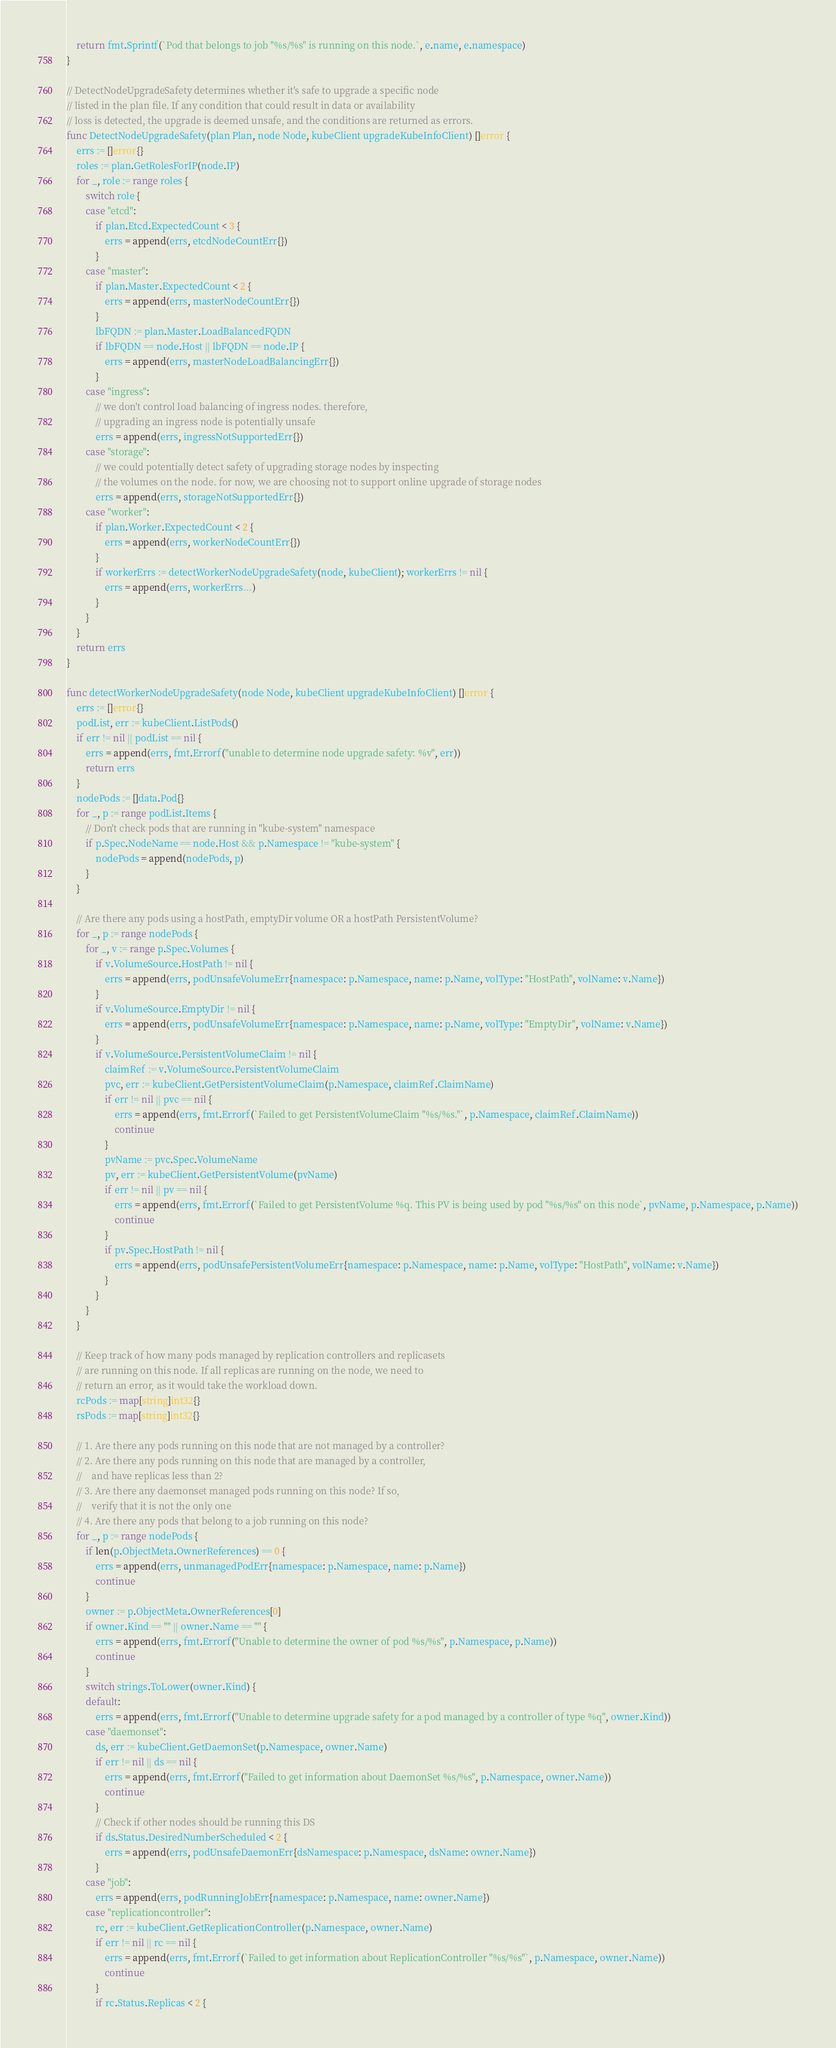<code> <loc_0><loc_0><loc_500><loc_500><_Go_>	return fmt.Sprintf(`Pod that belongs to job "%s/%s" is running on this node.`, e.name, e.namespace)
}

// DetectNodeUpgradeSafety determines whether it's safe to upgrade a specific node
// listed in the plan file. If any condition that could result in data or availability
// loss is detected, the upgrade is deemed unsafe, and the conditions are returned as errors.
func DetectNodeUpgradeSafety(plan Plan, node Node, kubeClient upgradeKubeInfoClient) []error {
	errs := []error{}
	roles := plan.GetRolesForIP(node.IP)
	for _, role := range roles {
		switch role {
		case "etcd":
			if plan.Etcd.ExpectedCount < 3 {
				errs = append(errs, etcdNodeCountErr{})
			}
		case "master":
			if plan.Master.ExpectedCount < 2 {
				errs = append(errs, masterNodeCountErr{})
			}
			lbFQDN := plan.Master.LoadBalancedFQDN
			if lbFQDN == node.Host || lbFQDN == node.IP {
				errs = append(errs, masterNodeLoadBalancingErr{})
			}
		case "ingress":
			// we don't control load balancing of ingress nodes. therefore,
			// upgrading an ingress node is potentially unsafe
			errs = append(errs, ingressNotSupportedErr{})
		case "storage":
			// we could potentially detect safety of upgrading storage nodes by inspecting
			// the volumes on the node. for now, we are choosing not to support online upgrade of storage nodes
			errs = append(errs, storageNotSupportedErr{})
		case "worker":
			if plan.Worker.ExpectedCount < 2 {
				errs = append(errs, workerNodeCountErr{})
			}
			if workerErrs := detectWorkerNodeUpgradeSafety(node, kubeClient); workerErrs != nil {
				errs = append(errs, workerErrs...)
			}
		}
	}
	return errs
}

func detectWorkerNodeUpgradeSafety(node Node, kubeClient upgradeKubeInfoClient) []error {
	errs := []error{}
	podList, err := kubeClient.ListPods()
	if err != nil || podList == nil {
		errs = append(errs, fmt.Errorf("unable to determine node upgrade safety: %v", err))
		return errs
	}
	nodePods := []data.Pod{}
	for _, p := range podList.Items {
		// Don't check pods that are running in "kube-system" namespace
		if p.Spec.NodeName == node.Host && p.Namespace != "kube-system" {
			nodePods = append(nodePods, p)
		}
	}

	// Are there any pods using a hostPath, emptyDir volume OR a hostPath PersistentVolume?
	for _, p := range nodePods {
		for _, v := range p.Spec.Volumes {
			if v.VolumeSource.HostPath != nil {
				errs = append(errs, podUnsafeVolumeErr{namespace: p.Namespace, name: p.Name, volType: "HostPath", volName: v.Name})
			}
			if v.VolumeSource.EmptyDir != nil {
				errs = append(errs, podUnsafeVolumeErr{namespace: p.Namespace, name: p.Name, volType: "EmptyDir", volName: v.Name})
			}
			if v.VolumeSource.PersistentVolumeClaim != nil {
				claimRef := v.VolumeSource.PersistentVolumeClaim
				pvc, err := kubeClient.GetPersistentVolumeClaim(p.Namespace, claimRef.ClaimName)
				if err != nil || pvc == nil {
					errs = append(errs, fmt.Errorf(`Failed to get PersistentVolumeClaim "%s/%s."`, p.Namespace, claimRef.ClaimName))
					continue
				}
				pvName := pvc.Spec.VolumeName
				pv, err := kubeClient.GetPersistentVolume(pvName)
				if err != nil || pv == nil {
					errs = append(errs, fmt.Errorf(`Failed to get PersistentVolume %q. This PV is being used by pod "%s/%s" on this node`, pvName, p.Namespace, p.Name))
					continue
				}
				if pv.Spec.HostPath != nil {
					errs = append(errs, podUnsafePersistentVolumeErr{namespace: p.Namespace, name: p.Name, volType: "HostPath", volName: v.Name})
				}
			}
		}
	}

	// Keep track of how many pods managed by replication controllers and replicasets
	// are running on this node. If all replicas are running on the node, we need to
	// return an error, as it would take the workload down.
	rcPods := map[string]int32{}
	rsPods := map[string]int32{}

	// 1. Are there any pods running on this node that are not managed by a controller?
	// 2. Are there any pods running on this node that are managed by a controller,
	//    and have replicas less than 2?
	// 3. Are there any daemonset managed pods running on this node? If so,
	//    verify that it is not the only one
	// 4. Are there any pods that belong to a job running on this node?
	for _, p := range nodePods {
		if len(p.ObjectMeta.OwnerReferences) == 0 {
			errs = append(errs, unmanagedPodErr{namespace: p.Namespace, name: p.Name})
			continue
		}
		owner := p.ObjectMeta.OwnerReferences[0]
		if owner.Kind == "" || owner.Name == "" {
			errs = append(errs, fmt.Errorf("Unable to determine the owner of pod %s/%s", p.Namespace, p.Name))
			continue
		}
		switch strings.ToLower(owner.Kind) {
		default:
			errs = append(errs, fmt.Errorf("Unable to determine upgrade safety for a pod managed by a controller of type %q", owner.Kind))
		case "daemonset":
			ds, err := kubeClient.GetDaemonSet(p.Namespace, owner.Name)
			if err != nil || ds == nil {
				errs = append(errs, fmt.Errorf("Failed to get information about DaemonSet %s/%s", p.Namespace, owner.Name))
				continue
			}
			// Check if other nodes should be running this DS
			if ds.Status.DesiredNumberScheduled < 2 {
				errs = append(errs, podUnsafeDaemonErr{dsNamespace: p.Namespace, dsName: owner.Name})
			}
		case "job":
			errs = append(errs, podRunningJobErr{namespace: p.Namespace, name: owner.Name})
		case "replicationcontroller":
			rc, err := kubeClient.GetReplicationController(p.Namespace, owner.Name)
			if err != nil || rc == nil {
				errs = append(errs, fmt.Errorf(`Failed to get information about ReplicationController "%s/%s"`, p.Namespace, owner.Name))
				continue
			}
			if rc.Status.Replicas < 2 {</code> 